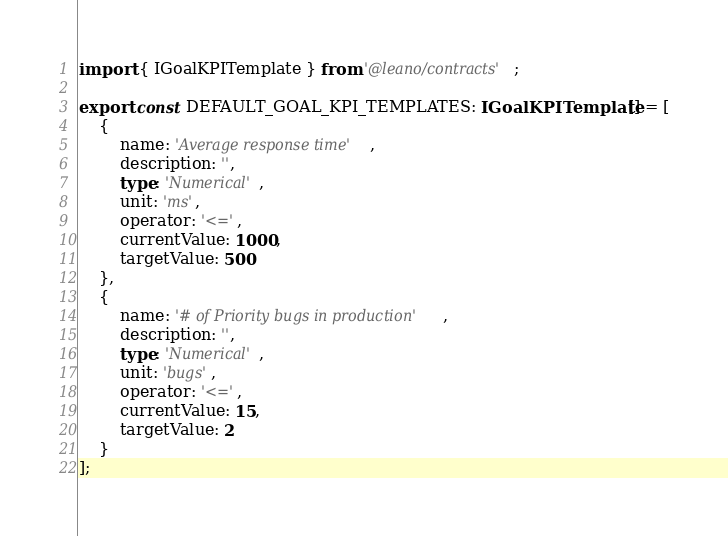<code> <loc_0><loc_0><loc_500><loc_500><_TypeScript_>import { IGoalKPITemplate } from '@leano/contracts';

export const DEFAULT_GOAL_KPI_TEMPLATES: IGoalKPITemplate[] = [
	{
		name: 'Average response time',
		description: '',
		type: 'Numerical',
		unit: 'ms',
		operator: '<=',
		currentValue: 1000,
		targetValue: 500
	},
	{
		name: '# of Priority bugs in production',
		description: '',
		type: 'Numerical',
		unit: 'bugs',
		operator: '<=',
		currentValue: 15,
		targetValue: 2
	}
];
</code> 